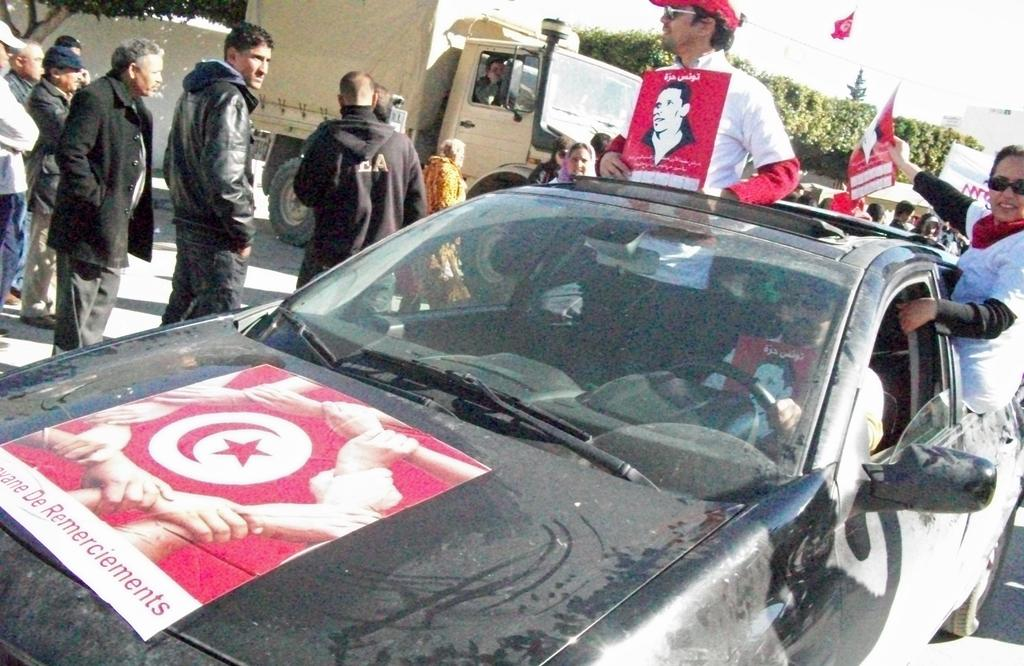How many people are in the car in the image? There are three people in the car in the image. What are the people in the car wearing on their shirts? The people in the car are wearing red posters on their shirts. What can be seen around the car in the image? There is a group of people around the car in the image. What is located behind the car in the image? There is a truck behind the car in the image. What type of plants can be seen growing on the control panel of the car in the image? There are no plants visible in the image, and the control panel of the car is not mentioned in the provided facts. 